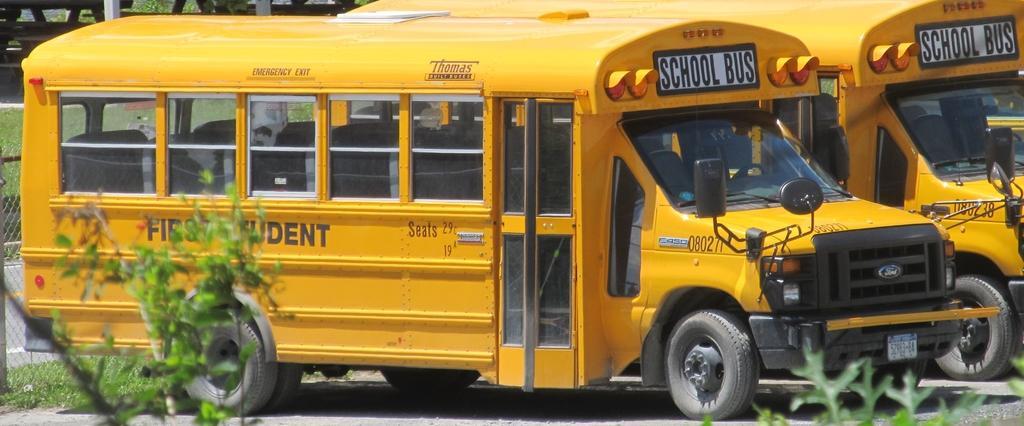Please provide a concise description of this image. This is an outside view. In this image I can see two yellow color vehicles on the road. At the bottom few leaves are visible. On the left side there is a net and I can see the grass on the ground. At the top of the image there are few metal objects. 